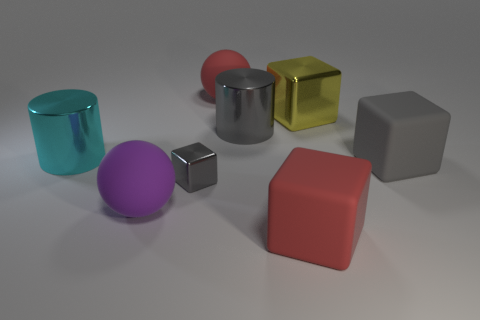There is a cylinder that is the same color as the tiny metallic block; what material is it?
Ensure brevity in your answer.  Metal. Are there any other things that are the same size as the gray metallic cube?
Your answer should be very brief. No. Is there another block that has the same color as the small cube?
Your answer should be very brief. Yes. There is a large ball in front of the large cyan shiny cylinder; what is its material?
Provide a succinct answer. Rubber. What number of tiny gray things have the same shape as the large gray rubber object?
Your answer should be very brief. 1. Do the large metallic block and the small shiny block have the same color?
Give a very brief answer. No. The gray cube that is right of the large red rubber object behind the big metallic cylinder that is behind the cyan cylinder is made of what material?
Offer a very short reply. Rubber. There is a big red rubber sphere; are there any yellow things on the left side of it?
Provide a short and direct response. No. What is the shape of the red thing that is the same size as the red matte ball?
Keep it short and to the point. Cube. Is the large purple object made of the same material as the small object?
Keep it short and to the point. No. 